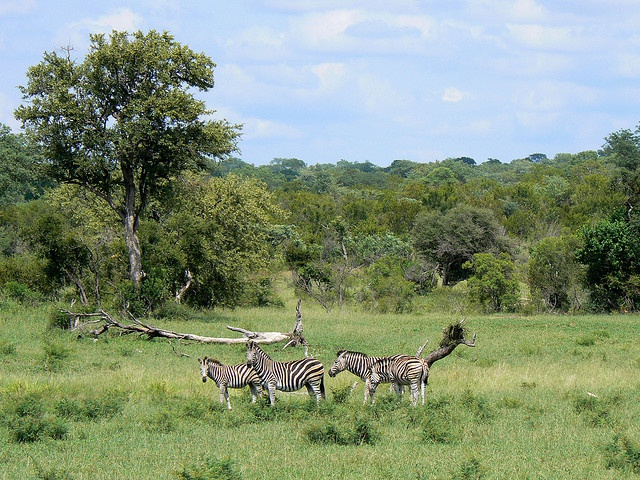Describe the objects in this image and their specific colors. I can see zebra in lavender, black, olive, gray, and ivory tones, zebra in lavender, black, ivory, gray, and darkgray tones, and zebra in lavender, black, lightgray, gray, and darkgray tones in this image. 